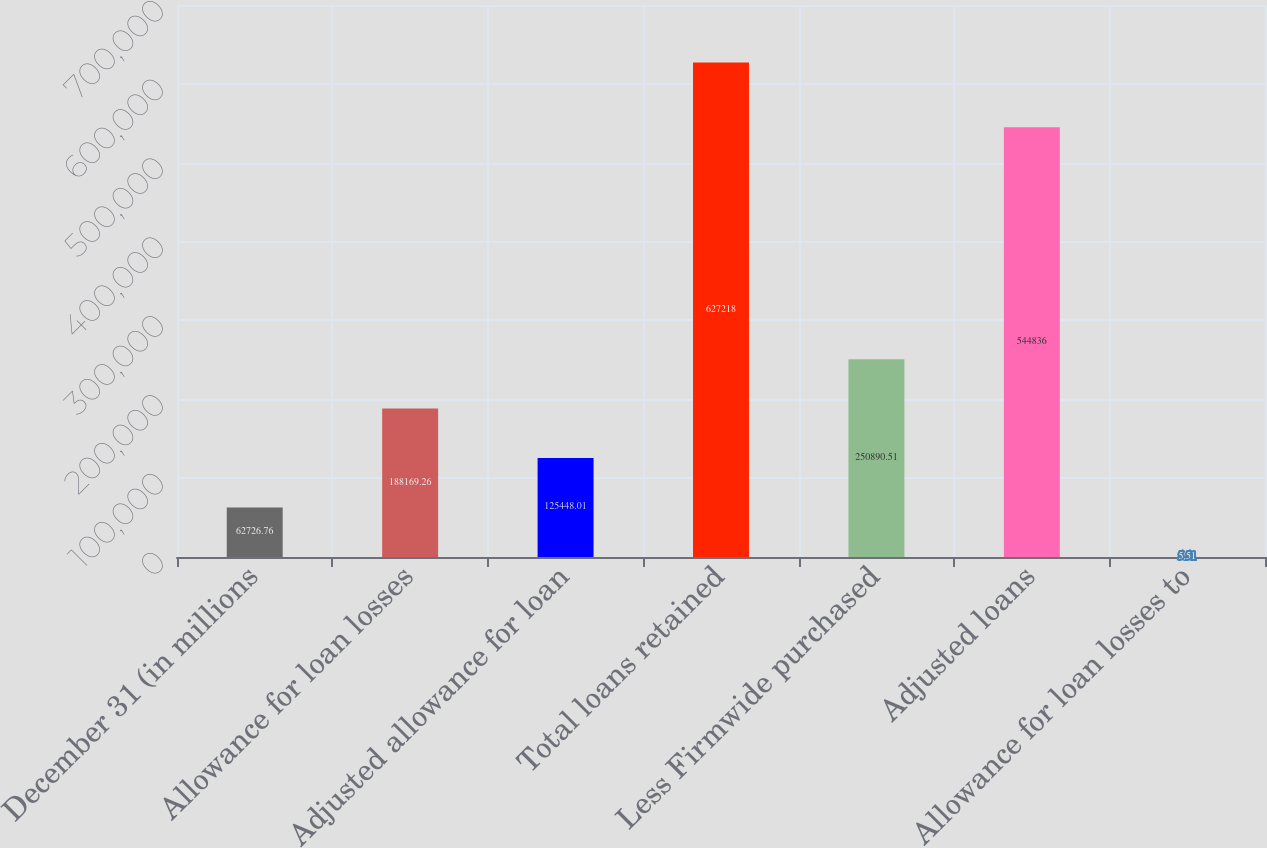Convert chart to OTSL. <chart><loc_0><loc_0><loc_500><loc_500><bar_chart><fcel>December 31 (in millions<fcel>Allowance for loan losses<fcel>Adjusted allowance for loan<fcel>Total loans retained<fcel>Less Firmwide purchased<fcel>Adjusted loans<fcel>Allowance for loan losses to<nl><fcel>62726.8<fcel>188169<fcel>125448<fcel>627218<fcel>250891<fcel>544836<fcel>5.51<nl></chart> 